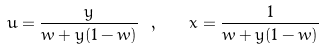<formula> <loc_0><loc_0><loc_500><loc_500>u = \frac { y } { w + y ( 1 - w ) } \ , \quad x = \frac { 1 } { w + y ( 1 - w ) }</formula> 